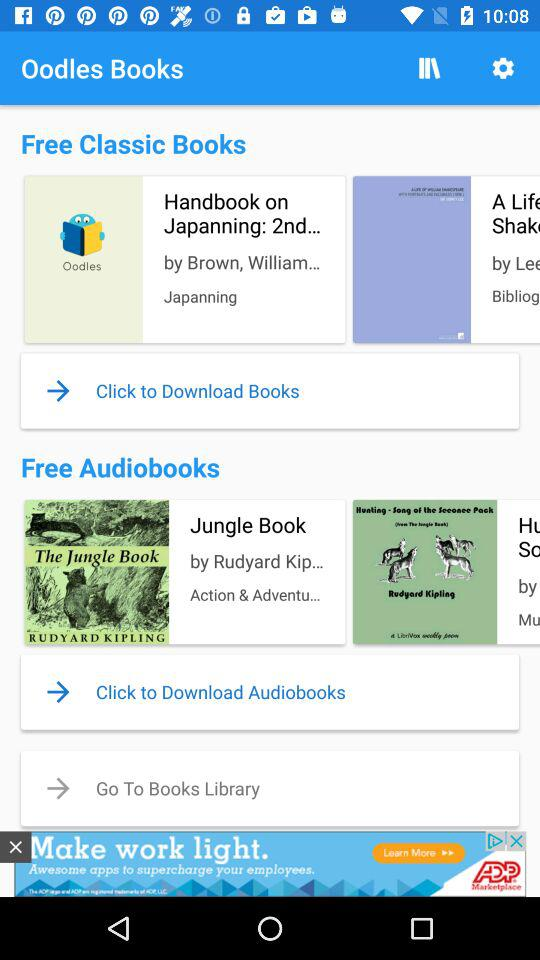Who is the writer of "Jungle Book"? The writer of "Jungle Book" is Rudyard Kipling. 